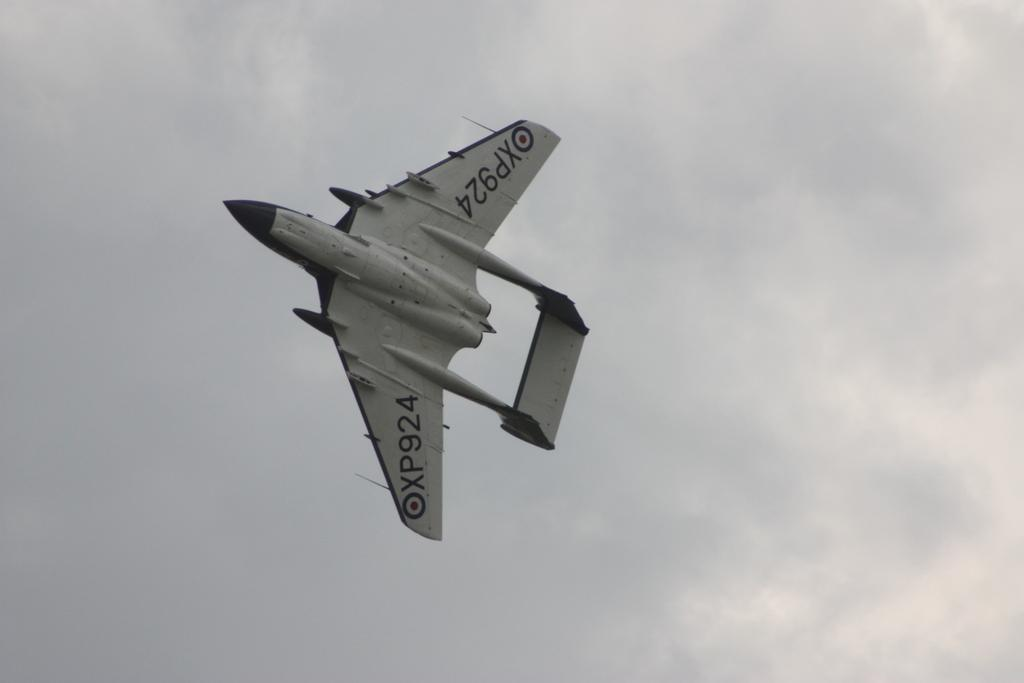<image>
Create a compact narrative representing the image presented. An airplane XP924 flies over head against the gray clouds. 